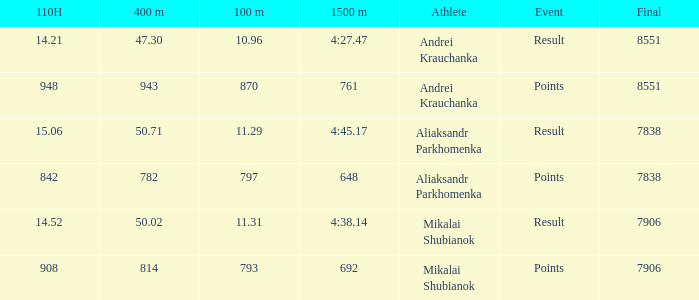What was the 100m that the 110H was less than 14.52 and the 400m was more than 47.3? None. 